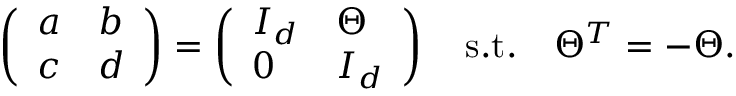Convert formula to latex. <formula><loc_0><loc_0><loc_500><loc_500>\left ( \begin{array} { l l } { a } & { b } \\ { c } & { d } \end{array} \right ) = \left ( \begin{array} { l l } { { I _ { d } } } & { \Theta } \\ { 0 } & { { I _ { d } } } \end{array} \right ) \quad s . t . \quad T h e t a ^ { T } = - \Theta .</formula> 